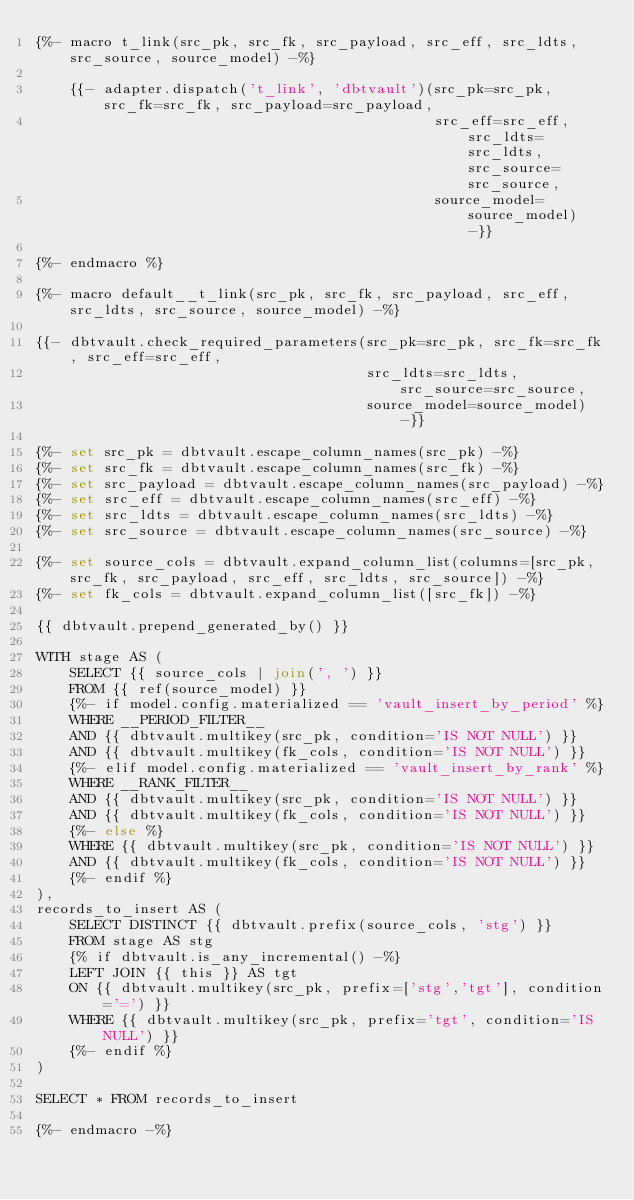Convert code to text. <code><loc_0><loc_0><loc_500><loc_500><_SQL_>{%- macro t_link(src_pk, src_fk, src_payload, src_eff, src_ldts, src_source, source_model) -%}

    {{- adapter.dispatch('t_link', 'dbtvault')(src_pk=src_pk, src_fk=src_fk, src_payload=src_payload,
                                               src_eff=src_eff, src_ldts=src_ldts, src_source=src_source,
                                               source_model=source_model) -}}

{%- endmacro %}

{%- macro default__t_link(src_pk, src_fk, src_payload, src_eff, src_ldts, src_source, source_model) -%}

{{- dbtvault.check_required_parameters(src_pk=src_pk, src_fk=src_fk, src_eff=src_eff,
                                       src_ldts=src_ldts, src_source=src_source,
                                       source_model=source_model) -}}

{%- set src_pk = dbtvault.escape_column_names(src_pk) -%}
{%- set src_fk = dbtvault.escape_column_names(src_fk) -%}
{%- set src_payload = dbtvault.escape_column_names(src_payload) -%}
{%- set src_eff = dbtvault.escape_column_names(src_eff) -%}
{%- set src_ldts = dbtvault.escape_column_names(src_ldts) -%}
{%- set src_source = dbtvault.escape_column_names(src_source) -%}

{%- set source_cols = dbtvault.expand_column_list(columns=[src_pk, src_fk, src_payload, src_eff, src_ldts, src_source]) -%}
{%- set fk_cols = dbtvault.expand_column_list([src_fk]) -%}

{{ dbtvault.prepend_generated_by() }}

WITH stage AS (
    SELECT {{ source_cols | join(', ') }}
    FROM {{ ref(source_model) }}
    {%- if model.config.materialized == 'vault_insert_by_period' %}
    WHERE __PERIOD_FILTER__
    AND {{ dbtvault.multikey(src_pk, condition='IS NOT NULL') }}
    AND {{ dbtvault.multikey(fk_cols, condition='IS NOT NULL') }}
    {%- elif model.config.materialized == 'vault_insert_by_rank' %}
    WHERE __RANK_FILTER__
    AND {{ dbtvault.multikey(src_pk, condition='IS NOT NULL') }}
    AND {{ dbtvault.multikey(fk_cols, condition='IS NOT NULL') }}
    {%- else %}
    WHERE {{ dbtvault.multikey(src_pk, condition='IS NOT NULL') }}
    AND {{ dbtvault.multikey(fk_cols, condition='IS NOT NULL') }}
    {%- endif %}
),
records_to_insert AS (
    SELECT DISTINCT {{ dbtvault.prefix(source_cols, 'stg') }}
    FROM stage AS stg
    {% if dbtvault.is_any_incremental() -%}
    LEFT JOIN {{ this }} AS tgt
    ON {{ dbtvault.multikey(src_pk, prefix=['stg','tgt'], condition='=') }}
    WHERE {{ dbtvault.multikey(src_pk, prefix='tgt', condition='IS NULL') }}
    {%- endif %}
)

SELECT * FROM records_to_insert

{%- endmacro -%}
</code> 